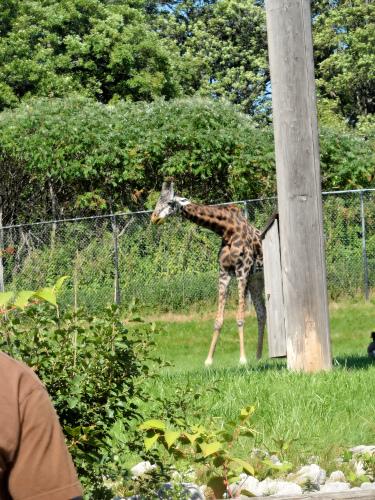What part of the fence is a strong deterrent?
Be succinct. Top. What type of animal is in the back?
Concise answer only. Giraffe. Is this giraffe in the wild?
Keep it brief. No. What is the name of the animal?
Short answer required. Giraffe. What color is the fence?
Answer briefly. Silver. Is this an adult giraffe?
Write a very short answer. No. How many giraffes are there?
Give a very brief answer. 1. What color is the man's shirt?
Short answer required. Brown. What season is it?
Keep it brief. Summer. 